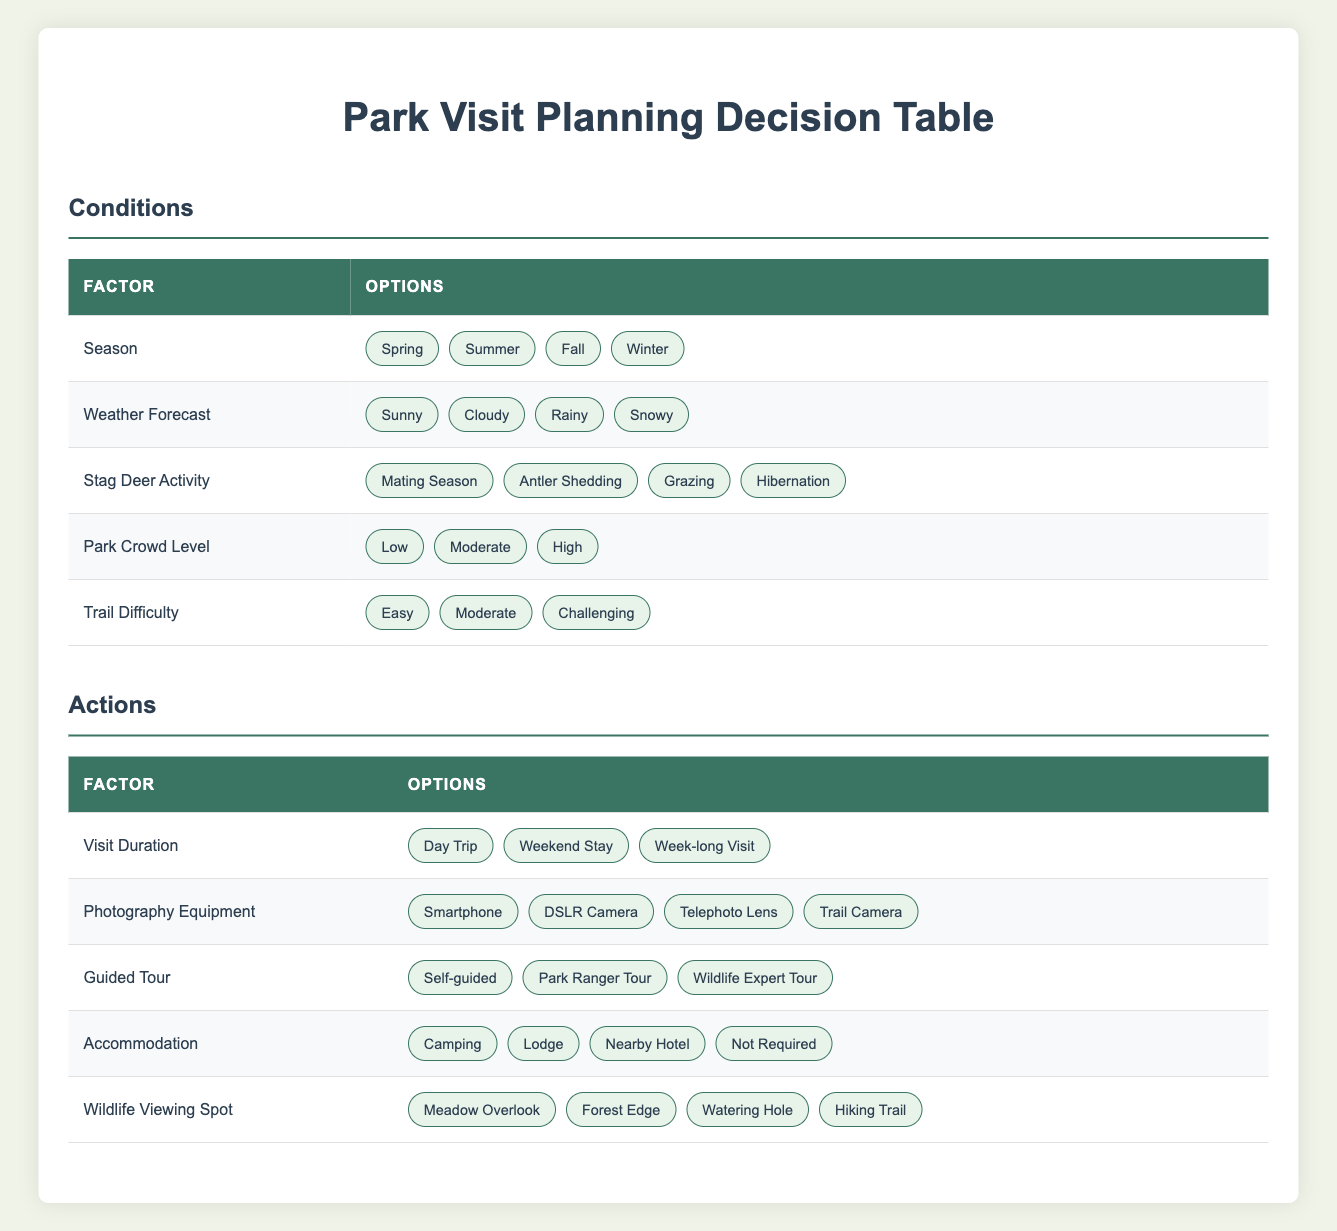What is the season with the most options for park visit planning? The table provides four options for the Season factor: Spring, Summer, Fall, and Winter. All seasons are equally represented with the same number of options, so the season does not have more options than the others.
Answer: All seasons have equal options Which guided tour type is available for visitors? The table lists three options for Guided Tour: Self-guided, Park Ranger Tour, and Wildlife Expert Tour. All these options are directly mentioned without any further calculations.
Answer: Self-guided, Park Ranger Tour, Wildlife Expert Tour Is Camping an option for Accommodation? The Accommodation options provided in the table are Camping, Lodge, Nearby Hotel, and Not Required. Since Camping is included in the list, the answer is affirmative.
Answer: Yes What are the options for Wildlife Viewing Spot? The table states four options for Wildlife Viewing Spot: Meadow Overlook, Forest Edge, Watering Hole, and Hiking Trail. These options can be directly retrieved from the table without any complex reasoning.
Answer: Meadow Overlook, Forest Edge, Watering Hole, Hiking Trail If it's a rainy day in Fall, what would be the recommended Visit Duration for optimal stag deer activity? While the table does not directly link specific stag deer activity to weather conditions or time of year, one might assume that a day trip would be optimal for mild stag activity, making it suitable for a rainy day. This decision is contextual rather than strictly numerical.
Answer: Day Trip What is the average number of options available for each factor? There are 5 conditions with 4 options each and 5 actions with 3 options each. The total number of options is (4 * 5) + (3 * 5) = 20 + 15 = 35 across 10 factors. Therefore, averaging this gives 35 / 10 = 3.5 options per factor.
Answer: 3.5 options Is it possible to have a challenging trail in a season when deer are mostly grazing? The table does not specify a relationship between the trail difficulty and stag deer activity. However, if the Grazing season is favorable for hiking, it is unlikely that a challenging trail would be recommended during that time due to safety and accessibility. The logical assumption is derived from general hiking practices.
Answer: Likely No What would be an ideal photography equipment to use during Mating Season if the weather is sunny? During Mating Season, stag deer are likely to be more active, making a Telephoto Lens an ideal choice to capture distant wildlife, especially in sunny weather that provides good lighting conditions. This combines the activity type and equipment effectiveness for optimal photography.
Answer: Telephoto Lens 